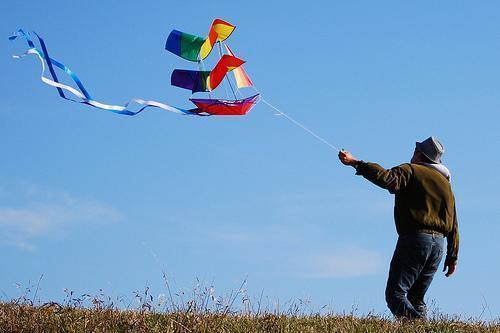How many people are shown?
Give a very brief answer. 1. 